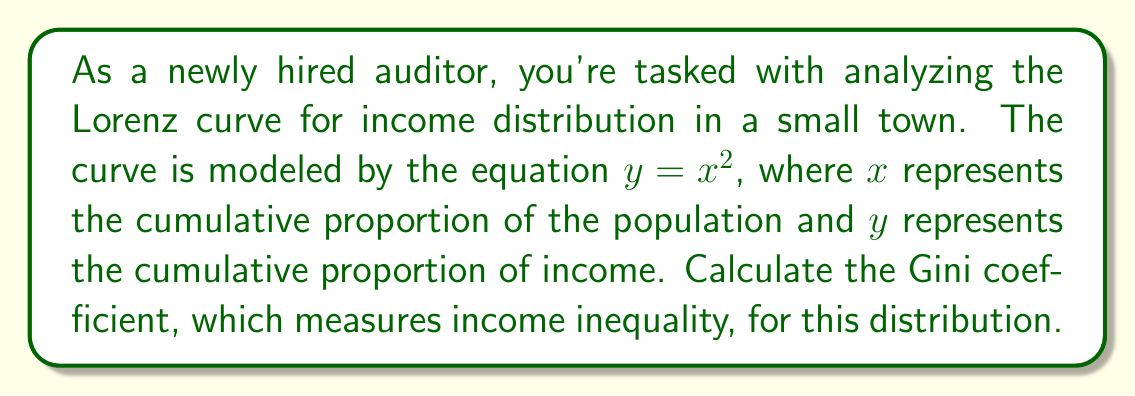Teach me how to tackle this problem. To solve this problem, let's follow these steps:

1) The Gini coefficient is calculated as the ratio of the area between the line of perfect equality (45-degree line) and the Lorenz curve to the total area under the line of perfect equality.

2) The line of perfect equality is represented by $y = x$.

3) The area between the line of perfect equality and the Lorenz curve is:

   $$A = \int_0^1 (x - x^2) dx$$

4) Let's solve this integral:
   
   $$A = [\frac{1}{2}x^2 - \frac{1}{3}x^3]_0^1 = (\frac{1}{2} - \frac{1}{3}) - (0 - 0) = \frac{1}{6}$$

5) The total area under the line of perfect equality is:

   $$\int_0^1 x dx = [\frac{1}{2}x^2]_0^1 = \frac{1}{2}$$

6) The Gini coefficient is the ratio of these areas:

   $$G = \frac{A}{\frac{1}{2}} = \frac{\frac{1}{6}}{\frac{1}{2}} = \frac{1}{3}$$

Therefore, the Gini coefficient for this income distribution is $\frac{1}{3}$ or approximately 0.333.
Answer: $\frac{1}{3}$ 